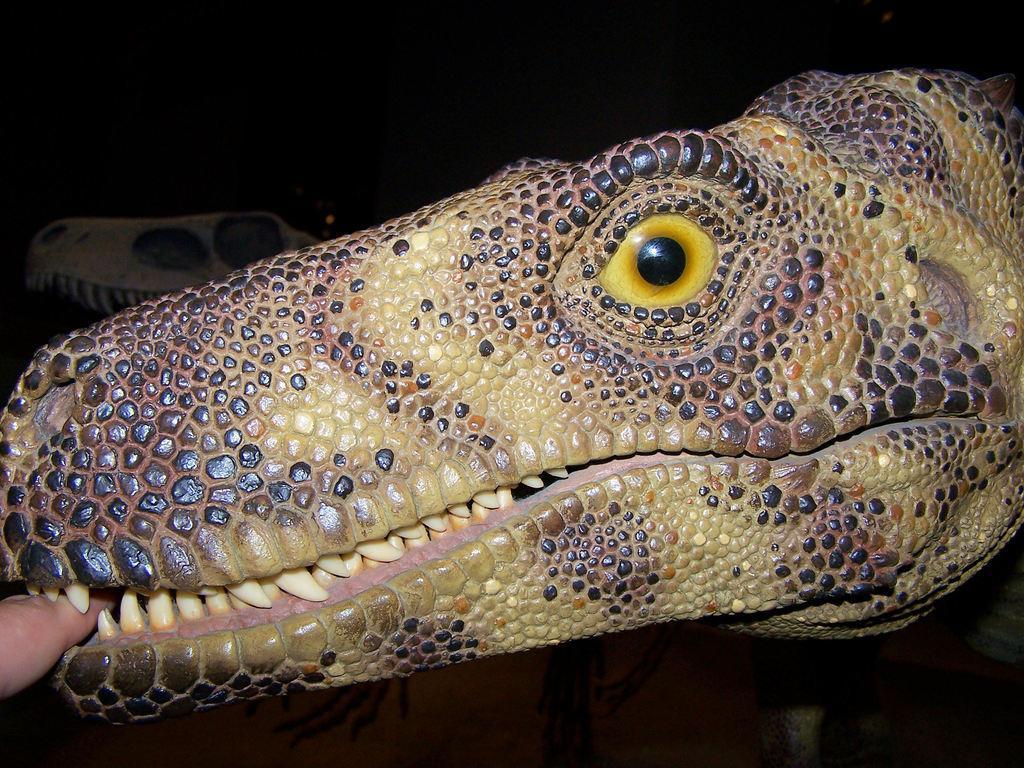How would you summarize this image in a sentence or two? In this image we can see two structures of the dinosaurs. The background is dark. We can see a human finger on the left side of the image. 